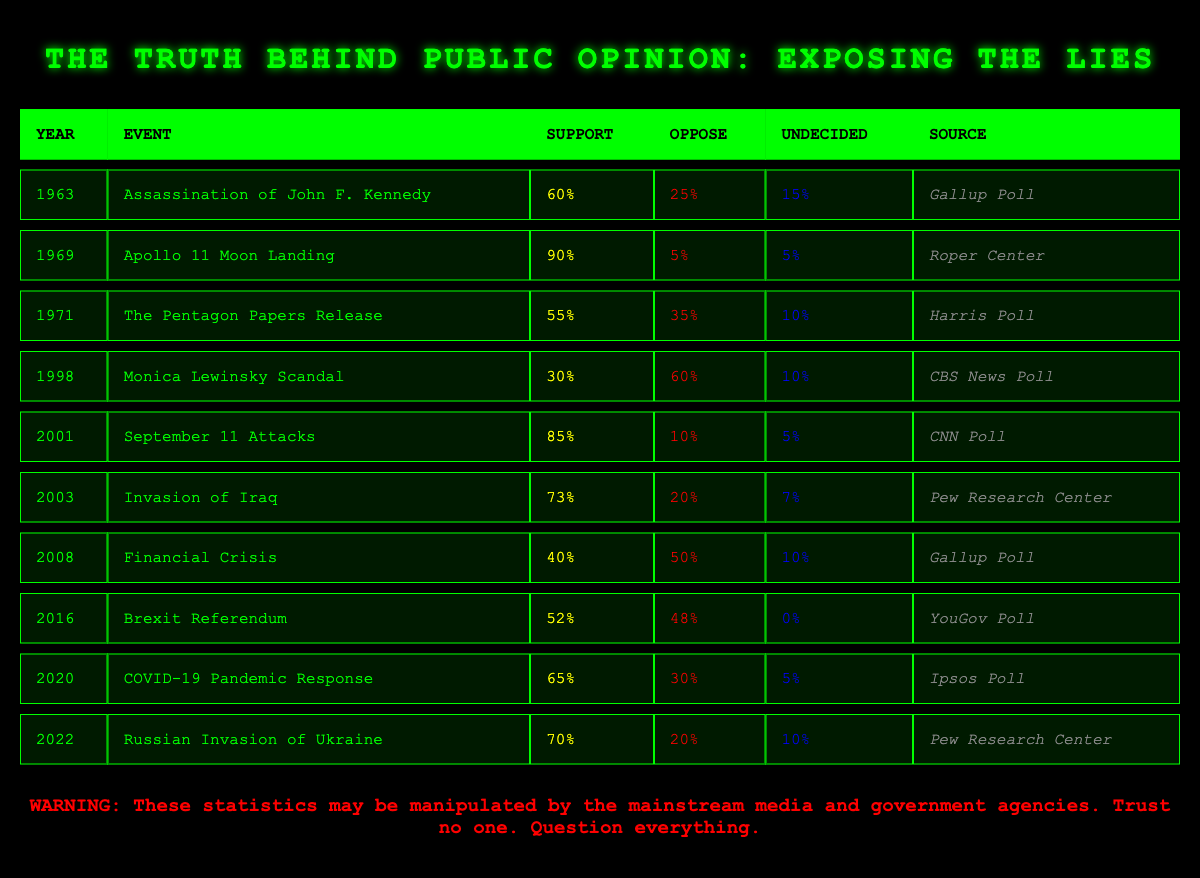What percentage of the public opposed the invasion of Iraq in 2003? According to the table, the percentage of public opposition to the invasion of Iraq in 2003 is listed under the "Oppose" column for that year, which states 20%.
Answer: 20% In which year did the Pentagon Papers release receive the lowest support percentage? By examining the "Support" column for the years 1971 (Pentagon Papers Release) and 1998 (Monica Lewinsky Scandal), the lowest support percentage is 30% for the Monica Lewinsky Scandal in 1998.
Answer: 1998 What is the difference in support percentages between the September 11 Attacks and the Financial Crisis? The support percentage for the September 11 Attacks in 2001 is 85%, while for the Financial Crisis in 2008 it is 40%. The difference is calculated as 85% - 40% = 45%.
Answer: 45% Were there more people undecided about Brexit in 2016 than those who supported the event? The table indicates that the percentage of undecided individuals for Brexit in 2016 is 0%, while the support is listed as 52%. Therefore, the answer to whether there were more undecided people than supporters is no.
Answer: No What is the average support percentage for the events listed between 2000 and 2010? The relevant support percentages for this period are from 2001 (85%), 2003 (73%), and 2008 (40%). To find the average, we sum these percentages: 85% + 73% + 40% = 198%. We then divide by the number of events (3), resulting in an average of 198% / 3 = 66%.
Answer: 66% 